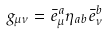Convert formula to latex. <formula><loc_0><loc_0><loc_500><loc_500>g _ { \mu \nu } = \bar { e } _ { \mu } ^ { a } \eta _ { a b } \bar { e } _ { \nu } ^ { b }</formula> 